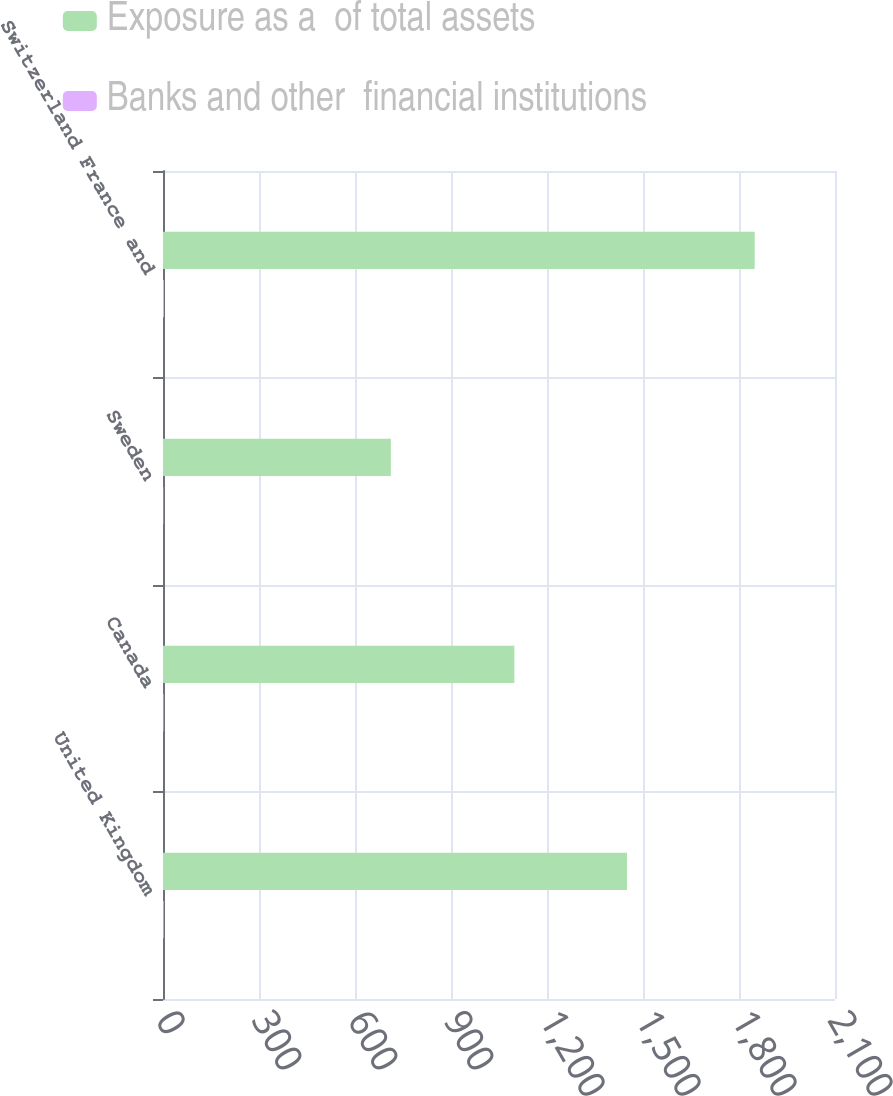Convert chart to OTSL. <chart><loc_0><loc_0><loc_500><loc_500><stacked_bar_chart><ecel><fcel>United Kingdom<fcel>Canada<fcel>Sweden<fcel>Switzerland France and<nl><fcel>Exposure as a  of total assets<fcel>1450<fcel>1098<fcel>712<fcel>1849<nl><fcel>Banks and other  financial institutions<fcel>2.2<fcel>1.7<fcel>1.1<fcel>2.8<nl></chart> 